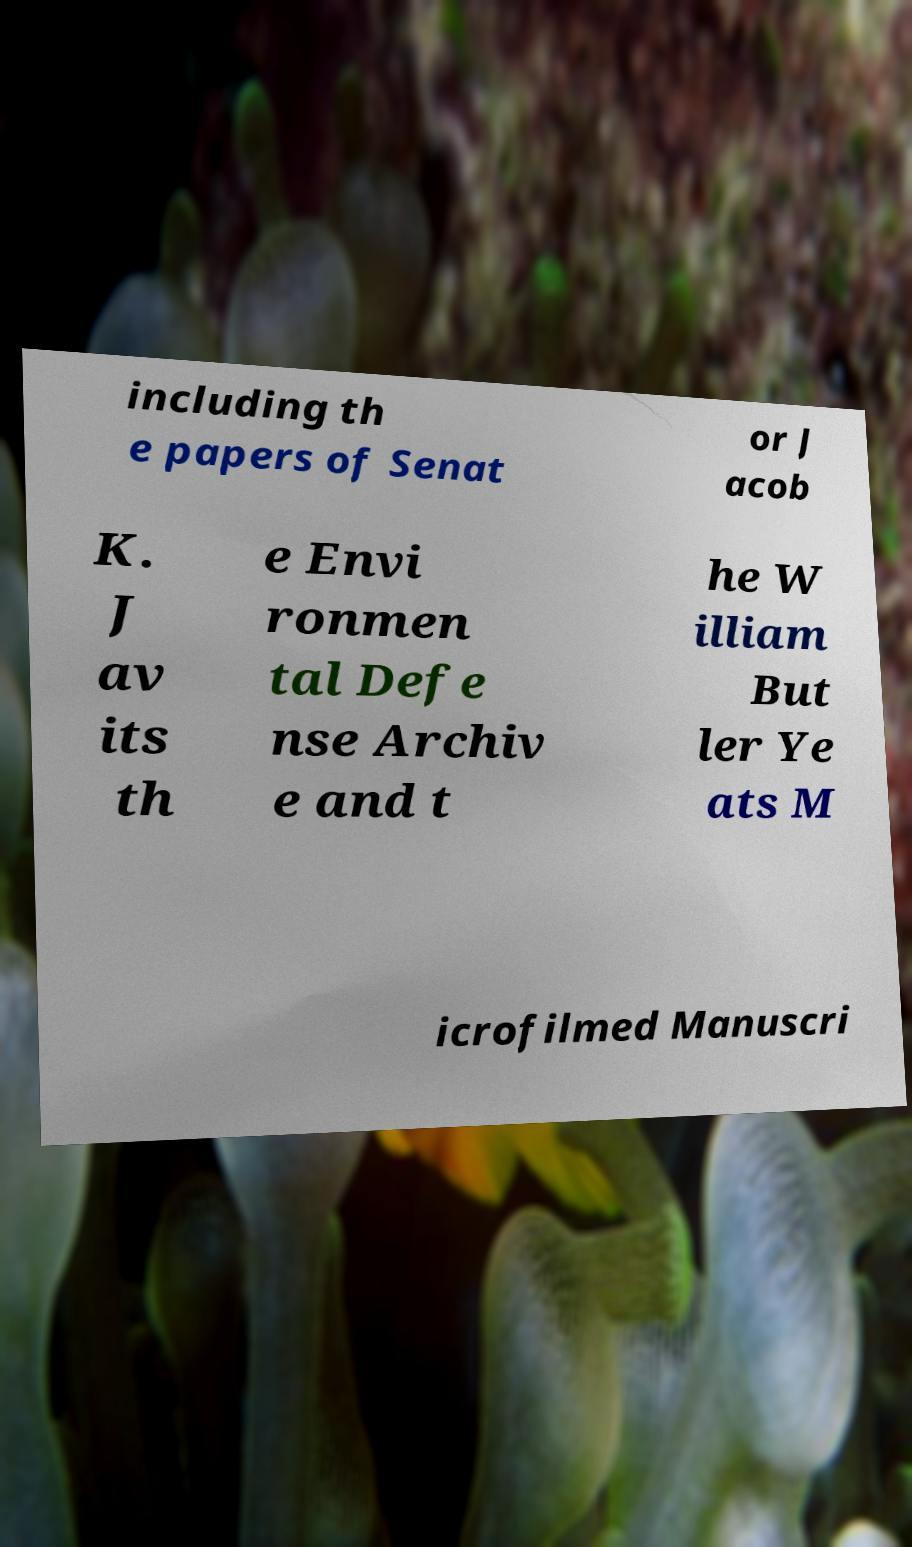Could you extract and type out the text from this image? including th e papers of Senat or J acob K. J av its th e Envi ronmen tal Defe nse Archiv e and t he W illiam But ler Ye ats M icrofilmed Manuscri 